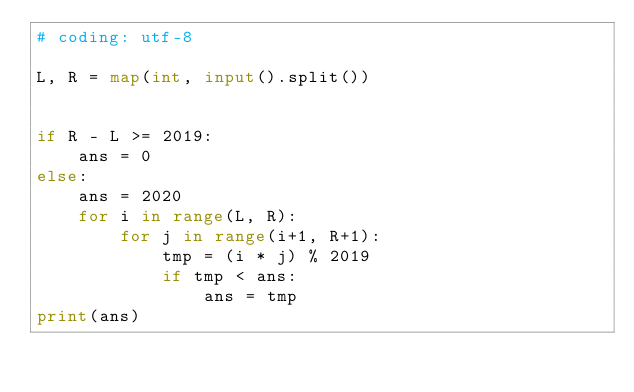Convert code to text. <code><loc_0><loc_0><loc_500><loc_500><_Python_># coding: utf-8

L, R = map(int, input().split())


if R - L >= 2019:
    ans = 0
else:
    ans = 2020
    for i in range(L, R):
        for j in range(i+1, R+1):
            tmp = (i * j) % 2019
            if tmp < ans:
                ans = tmp
print(ans)
</code> 